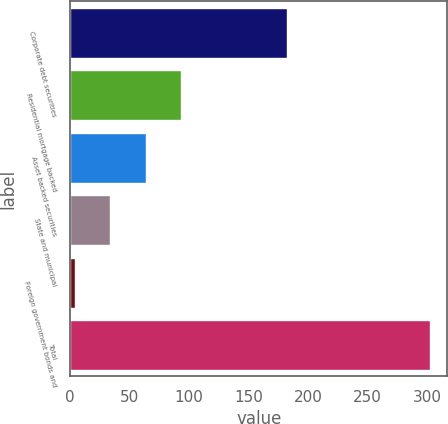<chart> <loc_0><loc_0><loc_500><loc_500><bar_chart><fcel>Corporate debt securities<fcel>Residential mortgage backed<fcel>Asset backed securities<fcel>State and municipal<fcel>Foreign government bonds and<fcel>Total<nl><fcel>182<fcel>93.4<fcel>63.6<fcel>33.8<fcel>4<fcel>302<nl></chart> 